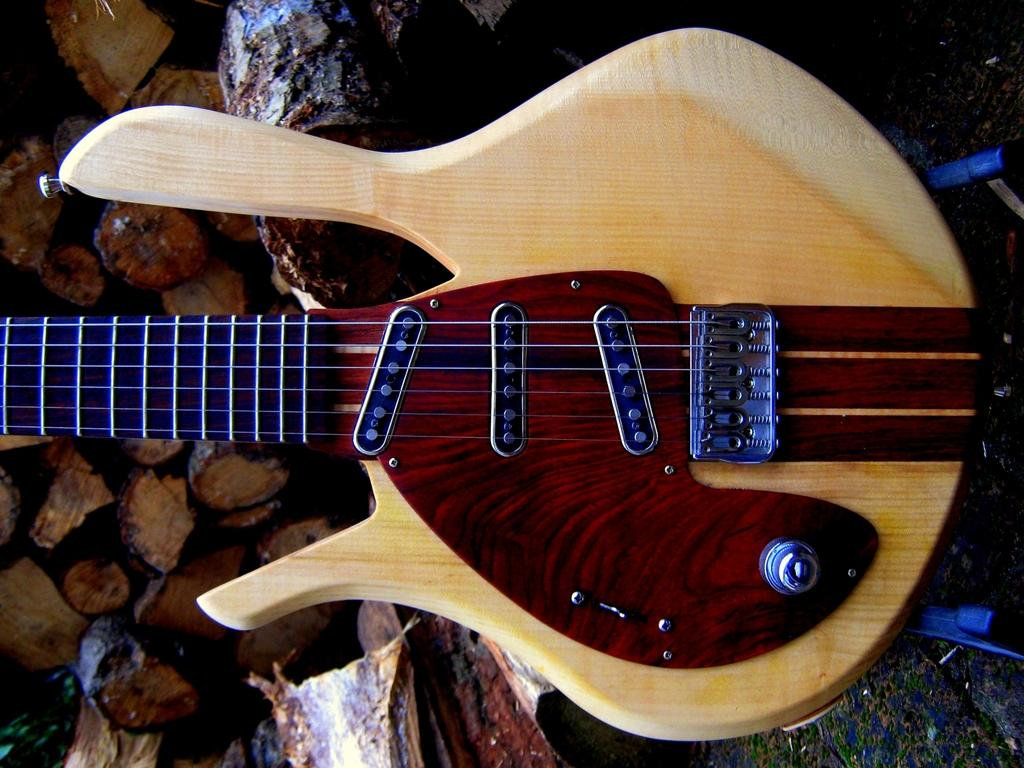What musical instrument is present in the image? There is a guitar in the image. Where is the guitar located? The guitar is on the floor. What can be seen on the left side of the image? There are pieces of wood on the left side of the image. How many buttons can be seen on the guitar in the image? There are no buttons visible on the guitar in the image. Is there a hill in the background of the image? There is no hill present in the image. 